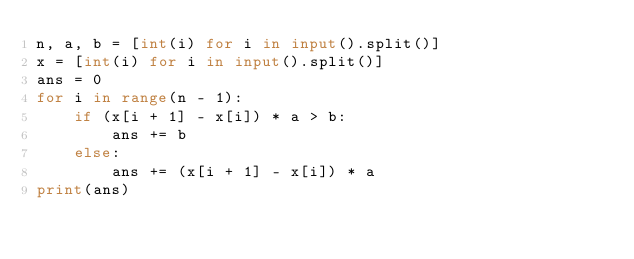<code> <loc_0><loc_0><loc_500><loc_500><_Python_>n, a, b = [int(i) for i in input().split()]
x = [int(i) for i in input().split()]
ans = 0
for i in range(n - 1):
    if (x[i + 1] - x[i]) * a > b:
        ans += b
    else:
        ans += (x[i + 1] - x[i]) * a
print(ans)        </code> 